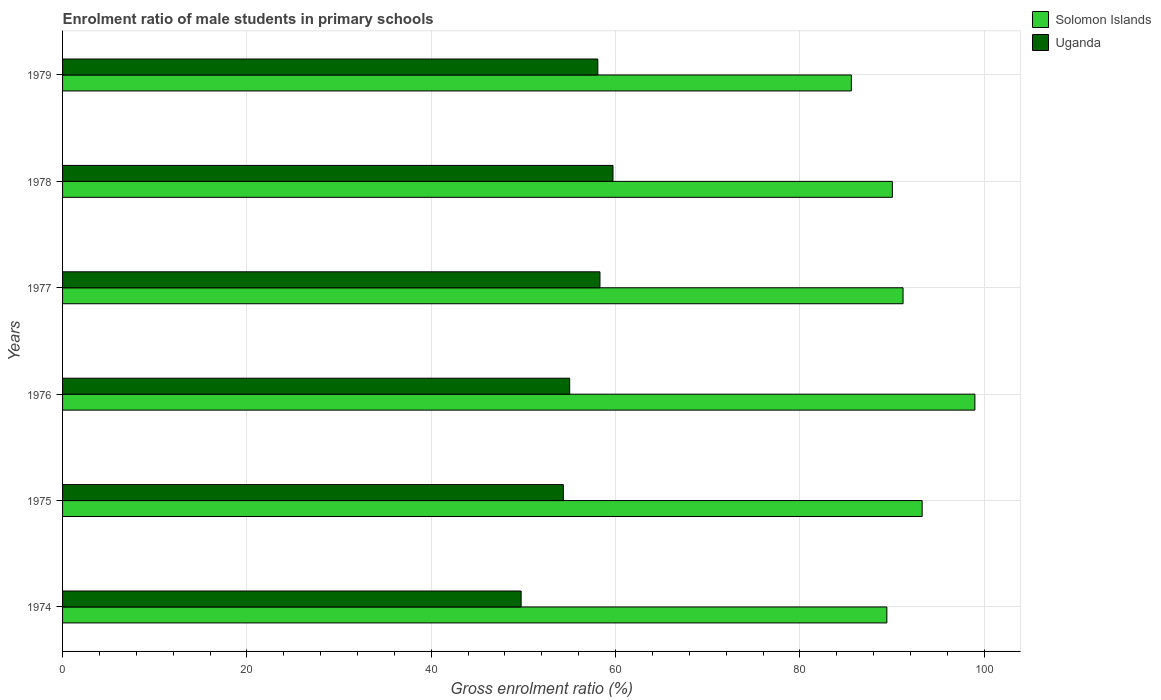How many different coloured bars are there?
Your answer should be very brief. 2. Are the number of bars per tick equal to the number of legend labels?
Offer a very short reply. Yes. In how many cases, is the number of bars for a given year not equal to the number of legend labels?
Your answer should be very brief. 0. What is the enrolment ratio of male students in primary schools in Solomon Islands in 1974?
Offer a terse response. 89.43. Across all years, what is the maximum enrolment ratio of male students in primary schools in Solomon Islands?
Your answer should be compact. 98.98. Across all years, what is the minimum enrolment ratio of male students in primary schools in Uganda?
Offer a very short reply. 49.75. In which year was the enrolment ratio of male students in primary schools in Uganda maximum?
Your answer should be very brief. 1978. In which year was the enrolment ratio of male students in primary schools in Uganda minimum?
Offer a terse response. 1974. What is the total enrolment ratio of male students in primary schools in Solomon Islands in the graph?
Offer a very short reply. 548.46. What is the difference between the enrolment ratio of male students in primary schools in Solomon Islands in 1978 and that in 1979?
Give a very brief answer. 4.45. What is the difference between the enrolment ratio of male students in primary schools in Uganda in 1978 and the enrolment ratio of male students in primary schools in Solomon Islands in 1975?
Provide a short and direct response. -33.54. What is the average enrolment ratio of male students in primary schools in Uganda per year?
Give a very brief answer. 55.87. In the year 1978, what is the difference between the enrolment ratio of male students in primary schools in Uganda and enrolment ratio of male students in primary schools in Solomon Islands?
Give a very brief answer. -30.31. In how many years, is the enrolment ratio of male students in primary schools in Uganda greater than 16 %?
Offer a terse response. 6. What is the ratio of the enrolment ratio of male students in primary schools in Uganda in 1975 to that in 1976?
Your answer should be very brief. 0.99. Is the enrolment ratio of male students in primary schools in Uganda in 1975 less than that in 1976?
Provide a short and direct response. Yes. Is the difference between the enrolment ratio of male students in primary schools in Uganda in 1977 and 1979 greater than the difference between the enrolment ratio of male students in primary schools in Solomon Islands in 1977 and 1979?
Ensure brevity in your answer.  No. What is the difference between the highest and the second highest enrolment ratio of male students in primary schools in Uganda?
Make the answer very short. 1.42. What is the difference between the highest and the lowest enrolment ratio of male students in primary schools in Solomon Islands?
Ensure brevity in your answer.  13.4. In how many years, is the enrolment ratio of male students in primary schools in Solomon Islands greater than the average enrolment ratio of male students in primary schools in Solomon Islands taken over all years?
Make the answer very short. 2. Is the sum of the enrolment ratio of male students in primary schools in Uganda in 1975 and 1978 greater than the maximum enrolment ratio of male students in primary schools in Solomon Islands across all years?
Give a very brief answer. Yes. What does the 2nd bar from the top in 1975 represents?
Your answer should be very brief. Solomon Islands. What does the 2nd bar from the bottom in 1974 represents?
Give a very brief answer. Uganda. How many bars are there?
Provide a succinct answer. 12. Are all the bars in the graph horizontal?
Keep it short and to the point. Yes. How many years are there in the graph?
Your response must be concise. 6. What is the difference between two consecutive major ticks on the X-axis?
Provide a short and direct response. 20. Are the values on the major ticks of X-axis written in scientific E-notation?
Offer a terse response. No. Does the graph contain any zero values?
Ensure brevity in your answer.  No. Where does the legend appear in the graph?
Provide a short and direct response. Top right. What is the title of the graph?
Offer a terse response. Enrolment ratio of male students in primary schools. What is the Gross enrolment ratio (%) of Solomon Islands in 1974?
Provide a short and direct response. 89.43. What is the Gross enrolment ratio (%) in Uganda in 1974?
Your answer should be very brief. 49.75. What is the Gross enrolment ratio (%) of Solomon Islands in 1975?
Your answer should be compact. 93.26. What is the Gross enrolment ratio (%) of Uganda in 1975?
Provide a short and direct response. 54.33. What is the Gross enrolment ratio (%) of Solomon Islands in 1976?
Ensure brevity in your answer.  98.98. What is the Gross enrolment ratio (%) of Uganda in 1976?
Offer a very short reply. 55.02. What is the Gross enrolment ratio (%) of Solomon Islands in 1977?
Offer a terse response. 91.19. What is the Gross enrolment ratio (%) of Uganda in 1977?
Your response must be concise. 58.3. What is the Gross enrolment ratio (%) in Solomon Islands in 1978?
Provide a succinct answer. 90.03. What is the Gross enrolment ratio (%) of Uganda in 1978?
Keep it short and to the point. 59.72. What is the Gross enrolment ratio (%) in Solomon Islands in 1979?
Give a very brief answer. 85.58. What is the Gross enrolment ratio (%) in Uganda in 1979?
Keep it short and to the point. 58.07. Across all years, what is the maximum Gross enrolment ratio (%) in Solomon Islands?
Give a very brief answer. 98.98. Across all years, what is the maximum Gross enrolment ratio (%) in Uganda?
Provide a short and direct response. 59.72. Across all years, what is the minimum Gross enrolment ratio (%) in Solomon Islands?
Make the answer very short. 85.58. Across all years, what is the minimum Gross enrolment ratio (%) of Uganda?
Give a very brief answer. 49.75. What is the total Gross enrolment ratio (%) in Solomon Islands in the graph?
Keep it short and to the point. 548.46. What is the total Gross enrolment ratio (%) of Uganda in the graph?
Your answer should be very brief. 335.19. What is the difference between the Gross enrolment ratio (%) in Solomon Islands in 1974 and that in 1975?
Give a very brief answer. -3.83. What is the difference between the Gross enrolment ratio (%) in Uganda in 1974 and that in 1975?
Your answer should be compact. -4.58. What is the difference between the Gross enrolment ratio (%) in Solomon Islands in 1974 and that in 1976?
Make the answer very short. -9.55. What is the difference between the Gross enrolment ratio (%) in Uganda in 1974 and that in 1976?
Ensure brevity in your answer.  -5.27. What is the difference between the Gross enrolment ratio (%) in Solomon Islands in 1974 and that in 1977?
Give a very brief answer. -1.76. What is the difference between the Gross enrolment ratio (%) in Uganda in 1974 and that in 1977?
Keep it short and to the point. -8.55. What is the difference between the Gross enrolment ratio (%) in Solomon Islands in 1974 and that in 1978?
Your answer should be very brief. -0.6. What is the difference between the Gross enrolment ratio (%) of Uganda in 1974 and that in 1978?
Offer a very short reply. -9.97. What is the difference between the Gross enrolment ratio (%) of Solomon Islands in 1974 and that in 1979?
Ensure brevity in your answer.  3.85. What is the difference between the Gross enrolment ratio (%) of Uganda in 1974 and that in 1979?
Offer a terse response. -8.32. What is the difference between the Gross enrolment ratio (%) of Solomon Islands in 1975 and that in 1976?
Your answer should be very brief. -5.72. What is the difference between the Gross enrolment ratio (%) in Uganda in 1975 and that in 1976?
Make the answer very short. -0.69. What is the difference between the Gross enrolment ratio (%) of Solomon Islands in 1975 and that in 1977?
Your response must be concise. 2.07. What is the difference between the Gross enrolment ratio (%) of Uganda in 1975 and that in 1977?
Give a very brief answer. -3.97. What is the difference between the Gross enrolment ratio (%) in Solomon Islands in 1975 and that in 1978?
Keep it short and to the point. 3.23. What is the difference between the Gross enrolment ratio (%) of Uganda in 1975 and that in 1978?
Your answer should be very brief. -5.39. What is the difference between the Gross enrolment ratio (%) in Solomon Islands in 1975 and that in 1979?
Keep it short and to the point. 7.68. What is the difference between the Gross enrolment ratio (%) in Uganda in 1975 and that in 1979?
Offer a terse response. -3.74. What is the difference between the Gross enrolment ratio (%) of Solomon Islands in 1976 and that in 1977?
Keep it short and to the point. 7.79. What is the difference between the Gross enrolment ratio (%) in Uganda in 1976 and that in 1977?
Keep it short and to the point. -3.28. What is the difference between the Gross enrolment ratio (%) in Solomon Islands in 1976 and that in 1978?
Offer a terse response. 8.96. What is the difference between the Gross enrolment ratio (%) of Uganda in 1976 and that in 1978?
Your response must be concise. -4.7. What is the difference between the Gross enrolment ratio (%) in Solomon Islands in 1976 and that in 1979?
Your answer should be very brief. 13.4. What is the difference between the Gross enrolment ratio (%) in Uganda in 1976 and that in 1979?
Provide a succinct answer. -3.05. What is the difference between the Gross enrolment ratio (%) in Solomon Islands in 1977 and that in 1978?
Provide a short and direct response. 1.16. What is the difference between the Gross enrolment ratio (%) in Uganda in 1977 and that in 1978?
Ensure brevity in your answer.  -1.42. What is the difference between the Gross enrolment ratio (%) of Solomon Islands in 1977 and that in 1979?
Your answer should be very brief. 5.61. What is the difference between the Gross enrolment ratio (%) of Uganda in 1977 and that in 1979?
Provide a short and direct response. 0.23. What is the difference between the Gross enrolment ratio (%) in Solomon Islands in 1978 and that in 1979?
Your response must be concise. 4.45. What is the difference between the Gross enrolment ratio (%) in Uganda in 1978 and that in 1979?
Provide a succinct answer. 1.65. What is the difference between the Gross enrolment ratio (%) in Solomon Islands in 1974 and the Gross enrolment ratio (%) in Uganda in 1975?
Your response must be concise. 35.1. What is the difference between the Gross enrolment ratio (%) in Solomon Islands in 1974 and the Gross enrolment ratio (%) in Uganda in 1976?
Give a very brief answer. 34.41. What is the difference between the Gross enrolment ratio (%) in Solomon Islands in 1974 and the Gross enrolment ratio (%) in Uganda in 1977?
Give a very brief answer. 31.13. What is the difference between the Gross enrolment ratio (%) in Solomon Islands in 1974 and the Gross enrolment ratio (%) in Uganda in 1978?
Offer a terse response. 29.71. What is the difference between the Gross enrolment ratio (%) of Solomon Islands in 1974 and the Gross enrolment ratio (%) of Uganda in 1979?
Ensure brevity in your answer.  31.36. What is the difference between the Gross enrolment ratio (%) in Solomon Islands in 1975 and the Gross enrolment ratio (%) in Uganda in 1976?
Your answer should be very brief. 38.24. What is the difference between the Gross enrolment ratio (%) of Solomon Islands in 1975 and the Gross enrolment ratio (%) of Uganda in 1977?
Provide a succinct answer. 34.96. What is the difference between the Gross enrolment ratio (%) in Solomon Islands in 1975 and the Gross enrolment ratio (%) in Uganda in 1978?
Keep it short and to the point. 33.54. What is the difference between the Gross enrolment ratio (%) of Solomon Islands in 1975 and the Gross enrolment ratio (%) of Uganda in 1979?
Make the answer very short. 35.19. What is the difference between the Gross enrolment ratio (%) of Solomon Islands in 1976 and the Gross enrolment ratio (%) of Uganda in 1977?
Keep it short and to the point. 40.68. What is the difference between the Gross enrolment ratio (%) of Solomon Islands in 1976 and the Gross enrolment ratio (%) of Uganda in 1978?
Ensure brevity in your answer.  39.26. What is the difference between the Gross enrolment ratio (%) in Solomon Islands in 1976 and the Gross enrolment ratio (%) in Uganda in 1979?
Offer a terse response. 40.91. What is the difference between the Gross enrolment ratio (%) in Solomon Islands in 1977 and the Gross enrolment ratio (%) in Uganda in 1978?
Your answer should be very brief. 31.47. What is the difference between the Gross enrolment ratio (%) in Solomon Islands in 1977 and the Gross enrolment ratio (%) in Uganda in 1979?
Offer a terse response. 33.12. What is the difference between the Gross enrolment ratio (%) in Solomon Islands in 1978 and the Gross enrolment ratio (%) in Uganda in 1979?
Your response must be concise. 31.95. What is the average Gross enrolment ratio (%) of Solomon Islands per year?
Give a very brief answer. 91.41. What is the average Gross enrolment ratio (%) of Uganda per year?
Your answer should be compact. 55.87. In the year 1974, what is the difference between the Gross enrolment ratio (%) in Solomon Islands and Gross enrolment ratio (%) in Uganda?
Offer a very short reply. 39.68. In the year 1975, what is the difference between the Gross enrolment ratio (%) of Solomon Islands and Gross enrolment ratio (%) of Uganda?
Provide a short and direct response. 38.93. In the year 1976, what is the difference between the Gross enrolment ratio (%) in Solomon Islands and Gross enrolment ratio (%) in Uganda?
Your answer should be very brief. 43.96. In the year 1977, what is the difference between the Gross enrolment ratio (%) in Solomon Islands and Gross enrolment ratio (%) in Uganda?
Keep it short and to the point. 32.89. In the year 1978, what is the difference between the Gross enrolment ratio (%) in Solomon Islands and Gross enrolment ratio (%) in Uganda?
Make the answer very short. 30.31. In the year 1979, what is the difference between the Gross enrolment ratio (%) in Solomon Islands and Gross enrolment ratio (%) in Uganda?
Keep it short and to the point. 27.51. What is the ratio of the Gross enrolment ratio (%) in Solomon Islands in 1974 to that in 1975?
Make the answer very short. 0.96. What is the ratio of the Gross enrolment ratio (%) of Uganda in 1974 to that in 1975?
Your response must be concise. 0.92. What is the ratio of the Gross enrolment ratio (%) in Solomon Islands in 1974 to that in 1976?
Provide a short and direct response. 0.9. What is the ratio of the Gross enrolment ratio (%) in Uganda in 1974 to that in 1976?
Your answer should be compact. 0.9. What is the ratio of the Gross enrolment ratio (%) of Solomon Islands in 1974 to that in 1977?
Offer a terse response. 0.98. What is the ratio of the Gross enrolment ratio (%) in Uganda in 1974 to that in 1977?
Keep it short and to the point. 0.85. What is the ratio of the Gross enrolment ratio (%) in Uganda in 1974 to that in 1978?
Your answer should be very brief. 0.83. What is the ratio of the Gross enrolment ratio (%) of Solomon Islands in 1974 to that in 1979?
Provide a short and direct response. 1.04. What is the ratio of the Gross enrolment ratio (%) of Uganda in 1974 to that in 1979?
Your response must be concise. 0.86. What is the ratio of the Gross enrolment ratio (%) of Solomon Islands in 1975 to that in 1976?
Ensure brevity in your answer.  0.94. What is the ratio of the Gross enrolment ratio (%) of Uganda in 1975 to that in 1976?
Provide a short and direct response. 0.99. What is the ratio of the Gross enrolment ratio (%) in Solomon Islands in 1975 to that in 1977?
Provide a short and direct response. 1.02. What is the ratio of the Gross enrolment ratio (%) in Uganda in 1975 to that in 1977?
Your response must be concise. 0.93. What is the ratio of the Gross enrolment ratio (%) of Solomon Islands in 1975 to that in 1978?
Your response must be concise. 1.04. What is the ratio of the Gross enrolment ratio (%) of Uganda in 1975 to that in 1978?
Offer a terse response. 0.91. What is the ratio of the Gross enrolment ratio (%) of Solomon Islands in 1975 to that in 1979?
Keep it short and to the point. 1.09. What is the ratio of the Gross enrolment ratio (%) in Uganda in 1975 to that in 1979?
Keep it short and to the point. 0.94. What is the ratio of the Gross enrolment ratio (%) of Solomon Islands in 1976 to that in 1977?
Provide a short and direct response. 1.09. What is the ratio of the Gross enrolment ratio (%) in Uganda in 1976 to that in 1977?
Your response must be concise. 0.94. What is the ratio of the Gross enrolment ratio (%) in Solomon Islands in 1976 to that in 1978?
Keep it short and to the point. 1.1. What is the ratio of the Gross enrolment ratio (%) of Uganda in 1976 to that in 1978?
Keep it short and to the point. 0.92. What is the ratio of the Gross enrolment ratio (%) in Solomon Islands in 1976 to that in 1979?
Your response must be concise. 1.16. What is the ratio of the Gross enrolment ratio (%) of Uganda in 1976 to that in 1979?
Your answer should be compact. 0.95. What is the ratio of the Gross enrolment ratio (%) in Solomon Islands in 1977 to that in 1978?
Offer a very short reply. 1.01. What is the ratio of the Gross enrolment ratio (%) of Uganda in 1977 to that in 1978?
Provide a short and direct response. 0.98. What is the ratio of the Gross enrolment ratio (%) of Solomon Islands in 1977 to that in 1979?
Provide a short and direct response. 1.07. What is the ratio of the Gross enrolment ratio (%) in Solomon Islands in 1978 to that in 1979?
Provide a succinct answer. 1.05. What is the ratio of the Gross enrolment ratio (%) of Uganda in 1978 to that in 1979?
Give a very brief answer. 1.03. What is the difference between the highest and the second highest Gross enrolment ratio (%) of Solomon Islands?
Your response must be concise. 5.72. What is the difference between the highest and the second highest Gross enrolment ratio (%) in Uganda?
Offer a very short reply. 1.42. What is the difference between the highest and the lowest Gross enrolment ratio (%) in Solomon Islands?
Provide a short and direct response. 13.4. What is the difference between the highest and the lowest Gross enrolment ratio (%) in Uganda?
Make the answer very short. 9.97. 